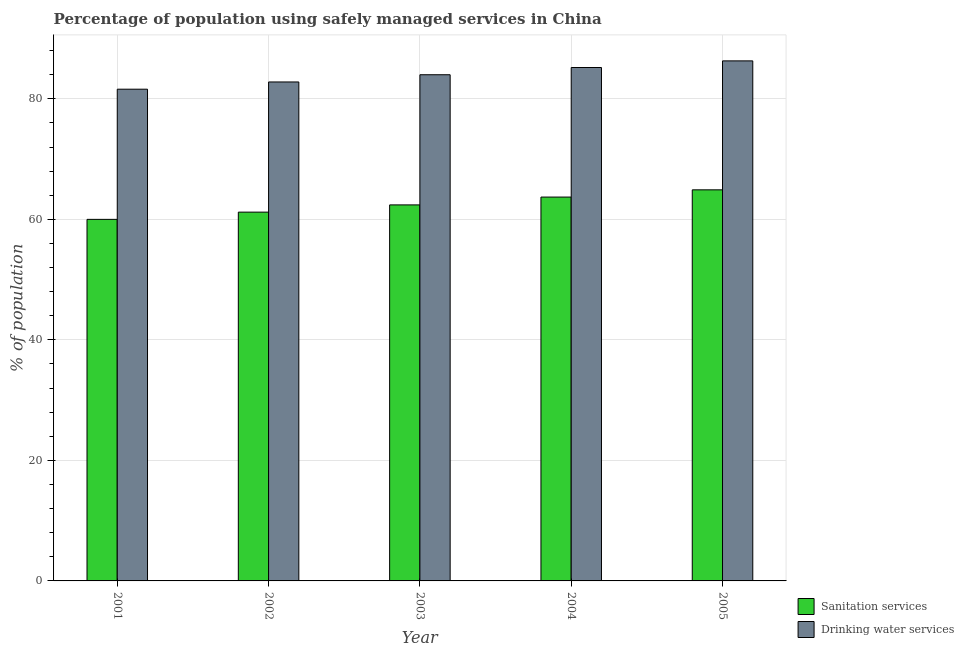Are the number of bars on each tick of the X-axis equal?
Keep it short and to the point. Yes. How many bars are there on the 3rd tick from the left?
Keep it short and to the point. 2. How many bars are there on the 4th tick from the right?
Offer a terse response. 2. What is the percentage of population who used drinking water services in 2004?
Keep it short and to the point. 85.2. Across all years, what is the maximum percentage of population who used drinking water services?
Provide a succinct answer. 86.3. Across all years, what is the minimum percentage of population who used drinking water services?
Keep it short and to the point. 81.6. In which year was the percentage of population who used drinking water services maximum?
Offer a very short reply. 2005. In which year was the percentage of population who used drinking water services minimum?
Provide a short and direct response. 2001. What is the total percentage of population who used drinking water services in the graph?
Ensure brevity in your answer.  419.9. What is the difference between the percentage of population who used sanitation services in 2003 and that in 2004?
Make the answer very short. -1.3. What is the difference between the percentage of population who used sanitation services in 2005 and the percentage of population who used drinking water services in 2002?
Make the answer very short. 3.7. What is the average percentage of population who used drinking water services per year?
Your answer should be very brief. 83.98. What is the ratio of the percentage of population who used drinking water services in 2001 to that in 2003?
Provide a short and direct response. 0.97. Is the percentage of population who used drinking water services in 2002 less than that in 2004?
Your answer should be very brief. Yes. What is the difference between the highest and the second highest percentage of population who used sanitation services?
Ensure brevity in your answer.  1.2. What is the difference between the highest and the lowest percentage of population who used drinking water services?
Offer a very short reply. 4.7. In how many years, is the percentage of population who used drinking water services greater than the average percentage of population who used drinking water services taken over all years?
Your response must be concise. 3. What does the 1st bar from the left in 2003 represents?
Your answer should be compact. Sanitation services. What does the 1st bar from the right in 2001 represents?
Keep it short and to the point. Drinking water services. Are the values on the major ticks of Y-axis written in scientific E-notation?
Ensure brevity in your answer.  No. Does the graph contain any zero values?
Your answer should be compact. No. Does the graph contain grids?
Offer a terse response. Yes. Where does the legend appear in the graph?
Your answer should be compact. Bottom right. How are the legend labels stacked?
Offer a very short reply. Vertical. What is the title of the graph?
Provide a succinct answer. Percentage of population using safely managed services in China. Does "Old" appear as one of the legend labels in the graph?
Your response must be concise. No. What is the label or title of the X-axis?
Offer a very short reply. Year. What is the label or title of the Y-axis?
Your answer should be very brief. % of population. What is the % of population in Drinking water services in 2001?
Make the answer very short. 81.6. What is the % of population in Sanitation services in 2002?
Provide a succinct answer. 61.2. What is the % of population of Drinking water services in 2002?
Give a very brief answer. 82.8. What is the % of population in Sanitation services in 2003?
Provide a succinct answer. 62.4. What is the % of population of Sanitation services in 2004?
Offer a terse response. 63.7. What is the % of population of Drinking water services in 2004?
Provide a short and direct response. 85.2. What is the % of population in Sanitation services in 2005?
Your response must be concise. 64.9. What is the % of population of Drinking water services in 2005?
Your answer should be compact. 86.3. Across all years, what is the maximum % of population of Sanitation services?
Offer a terse response. 64.9. Across all years, what is the maximum % of population in Drinking water services?
Give a very brief answer. 86.3. Across all years, what is the minimum % of population in Sanitation services?
Your response must be concise. 60. Across all years, what is the minimum % of population in Drinking water services?
Ensure brevity in your answer.  81.6. What is the total % of population of Sanitation services in the graph?
Offer a terse response. 312.2. What is the total % of population of Drinking water services in the graph?
Your answer should be compact. 419.9. What is the difference between the % of population of Sanitation services in 2001 and that in 2002?
Keep it short and to the point. -1.2. What is the difference between the % of population of Drinking water services in 2001 and that in 2003?
Offer a very short reply. -2.4. What is the difference between the % of population in Sanitation services in 2001 and that in 2004?
Ensure brevity in your answer.  -3.7. What is the difference between the % of population of Sanitation services in 2001 and that in 2005?
Your response must be concise. -4.9. What is the difference between the % of population in Drinking water services in 2001 and that in 2005?
Your response must be concise. -4.7. What is the difference between the % of population of Sanitation services in 2002 and that in 2003?
Offer a terse response. -1.2. What is the difference between the % of population of Drinking water services in 2002 and that in 2003?
Provide a succinct answer. -1.2. What is the difference between the % of population in Sanitation services in 2002 and that in 2004?
Make the answer very short. -2.5. What is the difference between the % of population of Drinking water services in 2002 and that in 2005?
Make the answer very short. -3.5. What is the difference between the % of population of Sanitation services in 2003 and that in 2004?
Offer a very short reply. -1.3. What is the difference between the % of population of Sanitation services in 2003 and that in 2005?
Offer a terse response. -2.5. What is the difference between the % of population in Sanitation services in 2004 and that in 2005?
Offer a very short reply. -1.2. What is the difference between the % of population of Sanitation services in 2001 and the % of population of Drinking water services in 2002?
Provide a short and direct response. -22.8. What is the difference between the % of population in Sanitation services in 2001 and the % of population in Drinking water services in 2004?
Your answer should be very brief. -25.2. What is the difference between the % of population in Sanitation services in 2001 and the % of population in Drinking water services in 2005?
Your answer should be very brief. -26.3. What is the difference between the % of population of Sanitation services in 2002 and the % of population of Drinking water services in 2003?
Make the answer very short. -22.8. What is the difference between the % of population of Sanitation services in 2002 and the % of population of Drinking water services in 2004?
Keep it short and to the point. -24. What is the difference between the % of population in Sanitation services in 2002 and the % of population in Drinking water services in 2005?
Make the answer very short. -25.1. What is the difference between the % of population in Sanitation services in 2003 and the % of population in Drinking water services in 2004?
Give a very brief answer. -22.8. What is the difference between the % of population of Sanitation services in 2003 and the % of population of Drinking water services in 2005?
Your response must be concise. -23.9. What is the difference between the % of population in Sanitation services in 2004 and the % of population in Drinking water services in 2005?
Give a very brief answer. -22.6. What is the average % of population in Sanitation services per year?
Make the answer very short. 62.44. What is the average % of population in Drinking water services per year?
Provide a succinct answer. 83.98. In the year 2001, what is the difference between the % of population of Sanitation services and % of population of Drinking water services?
Ensure brevity in your answer.  -21.6. In the year 2002, what is the difference between the % of population in Sanitation services and % of population in Drinking water services?
Offer a very short reply. -21.6. In the year 2003, what is the difference between the % of population in Sanitation services and % of population in Drinking water services?
Your answer should be very brief. -21.6. In the year 2004, what is the difference between the % of population of Sanitation services and % of population of Drinking water services?
Your answer should be very brief. -21.5. In the year 2005, what is the difference between the % of population in Sanitation services and % of population in Drinking water services?
Your answer should be compact. -21.4. What is the ratio of the % of population of Sanitation services in 2001 to that in 2002?
Provide a succinct answer. 0.98. What is the ratio of the % of population of Drinking water services in 2001 to that in 2002?
Make the answer very short. 0.99. What is the ratio of the % of population of Sanitation services in 2001 to that in 2003?
Your response must be concise. 0.96. What is the ratio of the % of population of Drinking water services in 2001 to that in 2003?
Your answer should be very brief. 0.97. What is the ratio of the % of population in Sanitation services in 2001 to that in 2004?
Your answer should be compact. 0.94. What is the ratio of the % of population in Drinking water services in 2001 to that in 2004?
Provide a short and direct response. 0.96. What is the ratio of the % of population in Sanitation services in 2001 to that in 2005?
Offer a terse response. 0.92. What is the ratio of the % of population of Drinking water services in 2001 to that in 2005?
Offer a terse response. 0.95. What is the ratio of the % of population in Sanitation services in 2002 to that in 2003?
Give a very brief answer. 0.98. What is the ratio of the % of population in Drinking water services in 2002 to that in 2003?
Provide a succinct answer. 0.99. What is the ratio of the % of population in Sanitation services in 2002 to that in 2004?
Ensure brevity in your answer.  0.96. What is the ratio of the % of population in Drinking water services in 2002 to that in 2004?
Your answer should be very brief. 0.97. What is the ratio of the % of population in Sanitation services in 2002 to that in 2005?
Offer a very short reply. 0.94. What is the ratio of the % of population of Drinking water services in 2002 to that in 2005?
Ensure brevity in your answer.  0.96. What is the ratio of the % of population in Sanitation services in 2003 to that in 2004?
Offer a very short reply. 0.98. What is the ratio of the % of population of Drinking water services in 2003 to that in 2004?
Keep it short and to the point. 0.99. What is the ratio of the % of population of Sanitation services in 2003 to that in 2005?
Your response must be concise. 0.96. What is the ratio of the % of population in Drinking water services in 2003 to that in 2005?
Provide a short and direct response. 0.97. What is the ratio of the % of population in Sanitation services in 2004 to that in 2005?
Your answer should be very brief. 0.98. What is the ratio of the % of population in Drinking water services in 2004 to that in 2005?
Your response must be concise. 0.99. What is the difference between the highest and the second highest % of population in Sanitation services?
Provide a short and direct response. 1.2. What is the difference between the highest and the second highest % of population of Drinking water services?
Make the answer very short. 1.1. What is the difference between the highest and the lowest % of population of Sanitation services?
Give a very brief answer. 4.9. What is the difference between the highest and the lowest % of population of Drinking water services?
Make the answer very short. 4.7. 